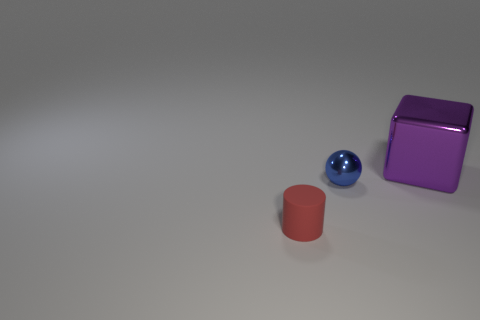How many other small balls have the same material as the small blue sphere?
Offer a very short reply. 0. There is a red matte cylinder; are there any small red matte cylinders to the right of it?
Your answer should be very brief. No. What is the big thing made of?
Keep it short and to the point. Metal. There is a thing left of the tiny blue ball; is it the same color as the cube?
Offer a very short reply. No. Is there any other thing that has the same shape as the red object?
Ensure brevity in your answer.  No. What is the material of the tiny thing to the right of the small red object?
Your response must be concise. Metal. What is the color of the cylinder?
Offer a terse response. Red. Does the thing that is behind the metallic ball have the same size as the red rubber cylinder?
Provide a succinct answer. No. The tiny thing that is to the right of the object in front of the small object that is behind the small red cylinder is made of what material?
Keep it short and to the point. Metal. Is the color of the small thing that is right of the cylinder the same as the metal thing on the right side of the shiny ball?
Keep it short and to the point. No. 